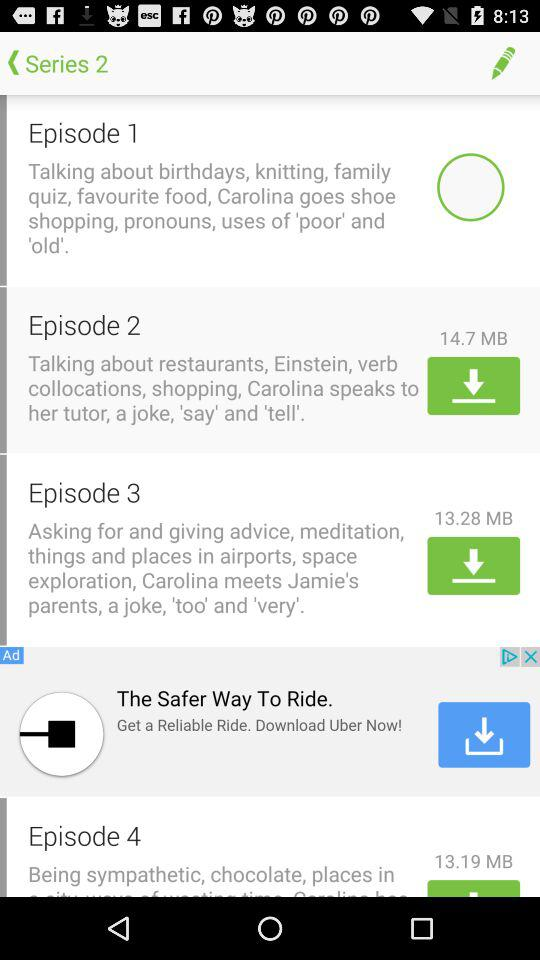How many episodes are in Series 2?
Answer the question using a single word or phrase. 4 